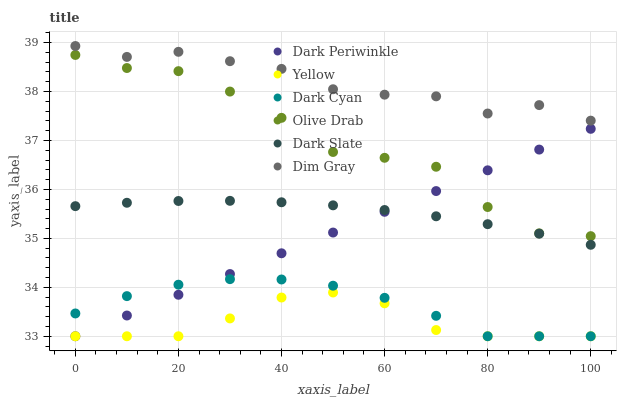Does Yellow have the minimum area under the curve?
Answer yes or no. Yes. Does Dim Gray have the maximum area under the curve?
Answer yes or no. Yes. Does Dark Slate have the minimum area under the curve?
Answer yes or no. No. Does Dark Slate have the maximum area under the curve?
Answer yes or no. No. Is Dark Periwinkle the smoothest?
Answer yes or no. Yes. Is Olive Drab the roughest?
Answer yes or no. Yes. Is Yellow the smoothest?
Answer yes or no. No. Is Yellow the roughest?
Answer yes or no. No. Does Yellow have the lowest value?
Answer yes or no. Yes. Does Dark Slate have the lowest value?
Answer yes or no. No. Does Dim Gray have the highest value?
Answer yes or no. Yes. Does Dark Slate have the highest value?
Answer yes or no. No. Is Yellow less than Olive Drab?
Answer yes or no. Yes. Is Olive Drab greater than Dark Cyan?
Answer yes or no. Yes. Does Dark Periwinkle intersect Dark Slate?
Answer yes or no. Yes. Is Dark Periwinkle less than Dark Slate?
Answer yes or no. No. Is Dark Periwinkle greater than Dark Slate?
Answer yes or no. No. Does Yellow intersect Olive Drab?
Answer yes or no. No. 